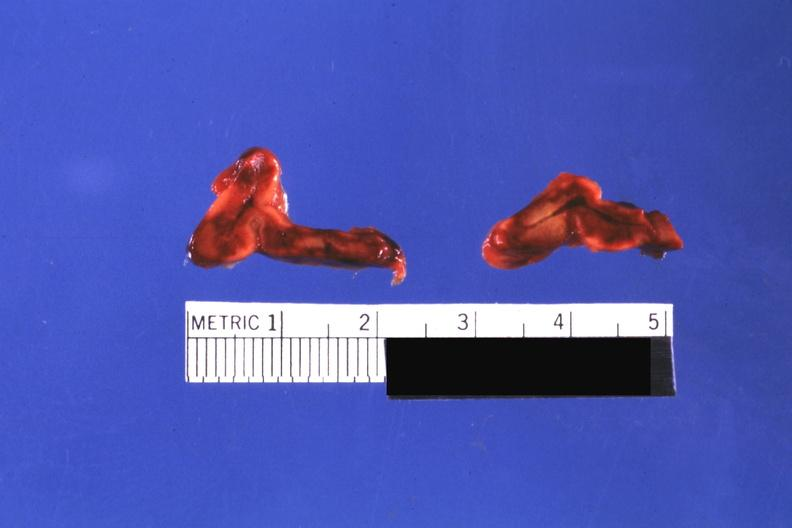s endocrine present?
Answer the question using a single word or phrase. Yes 